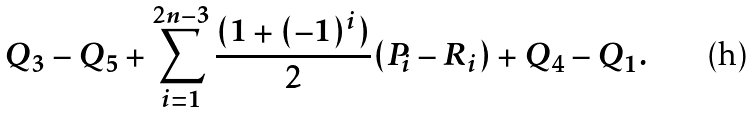Convert formula to latex. <formula><loc_0><loc_0><loc_500><loc_500>Q _ { 3 } - Q _ { 5 } + \sum _ { i = 1 } ^ { 2 n - 3 } \frac { ( 1 + ( - 1 ) ^ { i } ) } { 2 } ( P _ { i } - R _ { i } ) + Q _ { 4 } - Q _ { 1 } .</formula> 